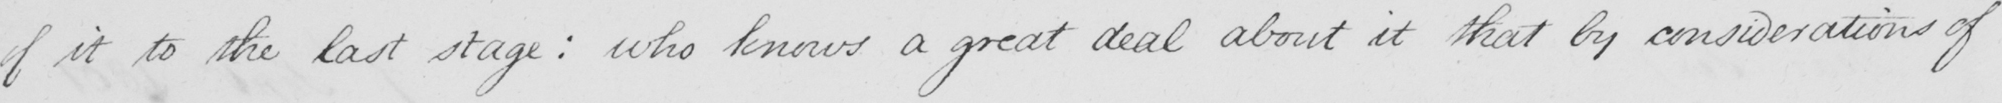Please transcribe the handwritten text in this image. of it to the last stage :  who knows a great deal about it that by considerations of 